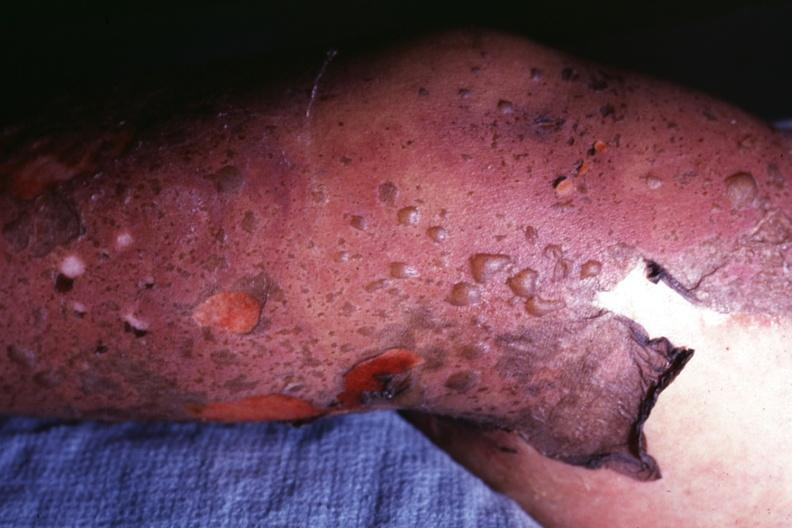s metastatic melanoma sure what it looks like?
Answer the question using a single word or phrase. No 